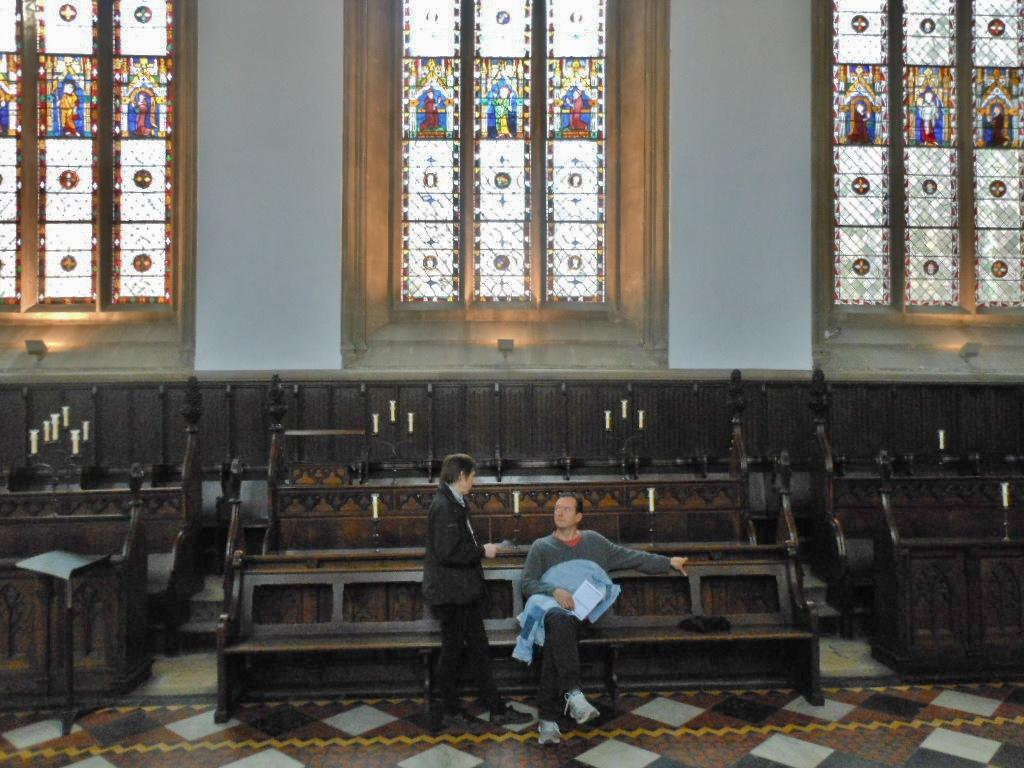Question: what kind of building is this?
Choices:
A. A church.
B. Library.
C. Gym.
D. Courthouse.
Answer with the letter. Answer: A Question: how many candles are there?
Choices:
A. 21.
B. 18.
C. 19.
D. 17.
Answer with the letter. Answer: D Question: what kind of shoes is the sitting man wearing?
Choices:
A. Loafers.
B. Sneakers.
C. Sandals.
D. Flip-flops.
Answer with the letter. Answer: B Question: who has portraits in the stained glass windows?
Choices:
A. Angels.
B. Jesus.
C. Saints.
D. Apostles.
Answer with the letter. Answer: C Question: where are the windows?
Choices:
A. Behind the men.
B. In the walls.
C. Isle three.
D. On a shelf.
Answer with the letter. Answer: A Question: who is holding a white piece of paper?
Choices:
A. The boy running.
B. The child playing.
C. The man sitting.
D. The woman walking.
Answer with the letter. Answer: C Question: what color is the zig zag line on the floor?
Choices:
A. Green.
B. Yellow.
C. Blue.
D. Purple.
Answer with the letter. Answer: B Question: what color hair do both men have?
Choices:
A. Brown.
B. Black.
C. Grey.
D. Blonde.
Answer with the letter. Answer: A Question: how many stained glass windows are there?
Choices:
A. Two.
B. Four.
C. Three.
D. One.
Answer with the letter. Answer: C Question: what is between the pews?
Choices:
A. Teenagers.
B. Toddlers.
C. Several candles.
D. Papers.
Answer with the letter. Answer: C Question: where is there a pattern with white squares?
Choices:
A. By the wall.
B. By the sofa.
C. On the chair.
D. On the floor.
Answer with the letter. Answer: D Question: who is talking to the seated man?
Choices:
A. A woman.
B. A redhead.
C. Someone else in the church.
D. A tall man.
Answer with the letter. Answer: C Question: what type of windows are those?
Choices:
A. Multi paned.
B. Leaded.
C. Stained glass.
D. Broken.
Answer with the letter. Answer: C Question: who is wearing a red shirt?
Choices:
A. The baby.
B. The girl.
C. The woman.
D. The seated man.
Answer with the letter. Answer: D Question: what is coming through the windows?
Choices:
A. Light.
B. Dust.
C. Smoke.
D. Steam.
Answer with the letter. Answer: A Question: who is holding a blue jacket?
Choices:
A. The standing woman.
B. The seated man.
C. The teenager.
D. The boy.
Answer with the letter. Answer: B Question: who is talking in the church?
Choices:
A. Two men.
B. Two women.
C. A family.
D. The pastor.
Answer with the letter. Answer: A Question: who else is in the church?
Choices:
A. The choir.
B. The Sunday school teacher.
C. No one.
D. The pastor.
Answer with the letter. Answer: C Question: what are the windows?
Choices:
A. Broken.
B. Dirty.
C. Stained glass.
D. Chipped.
Answer with the letter. Answer: C 